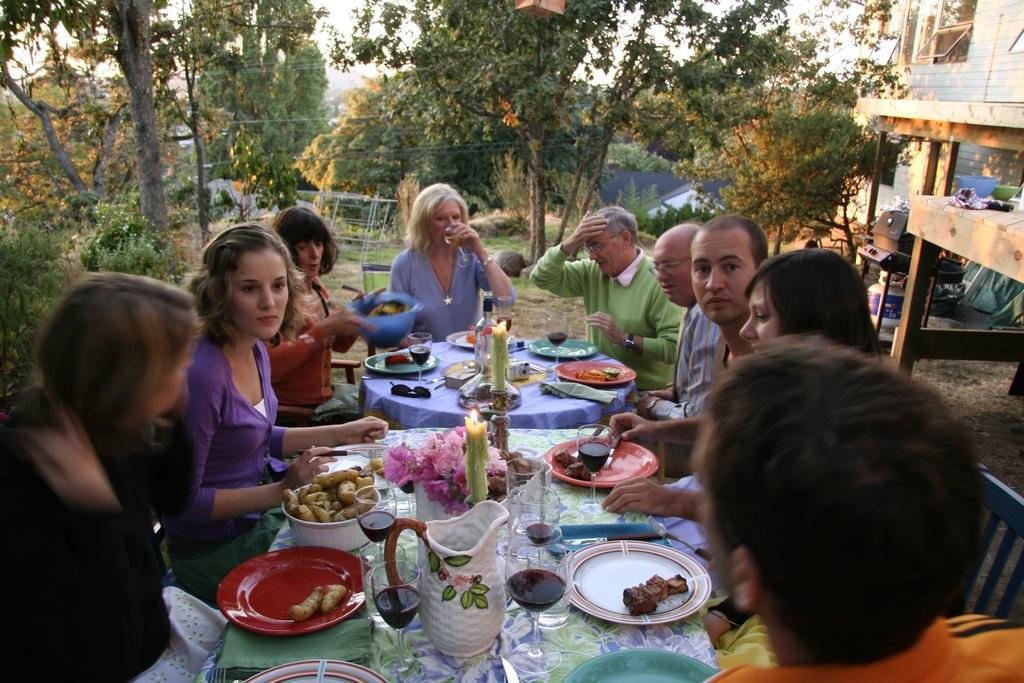What type of natural elements can be seen in the image? There are trees in the image. What type of man-made structures are present in the image? There are buildings in the image. What are the people in the image doing? The people are sitting on chairs in the image. How many tables are visible in the image? There are two tables in the image. What items can be seen on one of the tables? On one table, there is a mug, bowls, flowers, and plates. How many dolls are sitting on the chairs in the image? There are no dolls present in the image; there are people sitting on the chairs. Can you see an owl perched on one of the trees in the image? There is no owl present in the image; only trees are mentioned. 